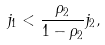Convert formula to latex. <formula><loc_0><loc_0><loc_500><loc_500>j _ { 1 } < \frac { \rho _ { 2 } } { 1 - \rho _ { 2 } } j _ { 2 } ,</formula> 